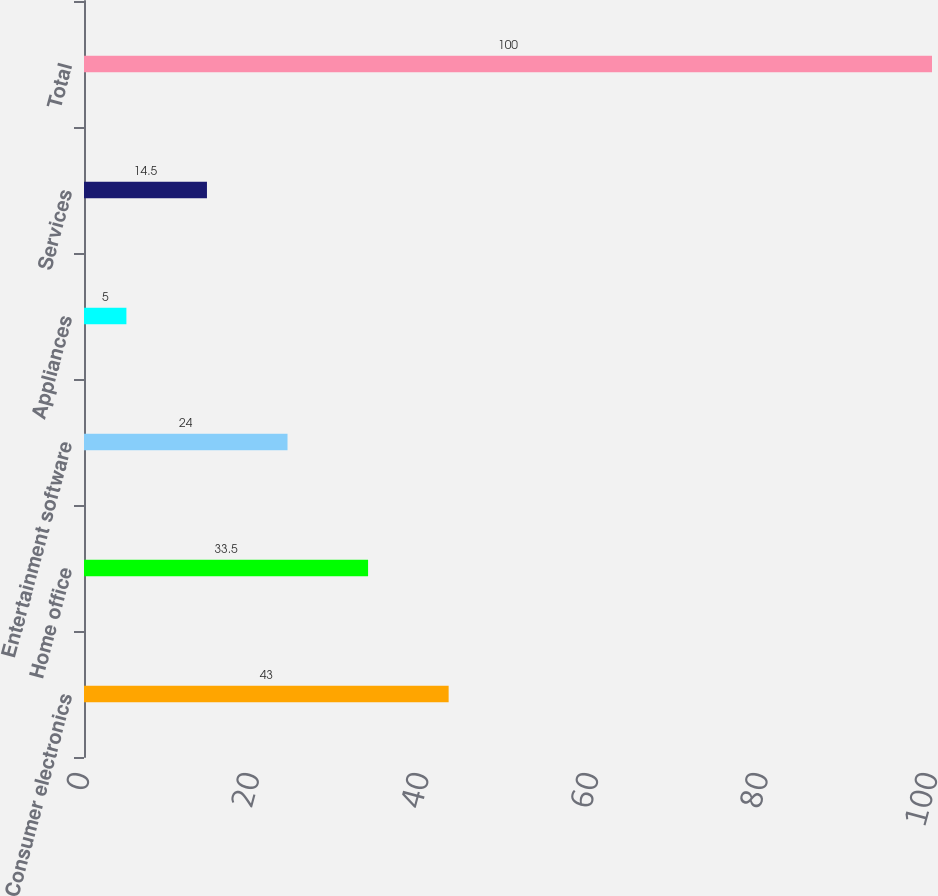Convert chart. <chart><loc_0><loc_0><loc_500><loc_500><bar_chart><fcel>Consumer electronics<fcel>Home office<fcel>Entertainment software<fcel>Appliances<fcel>Services<fcel>Total<nl><fcel>43<fcel>33.5<fcel>24<fcel>5<fcel>14.5<fcel>100<nl></chart> 